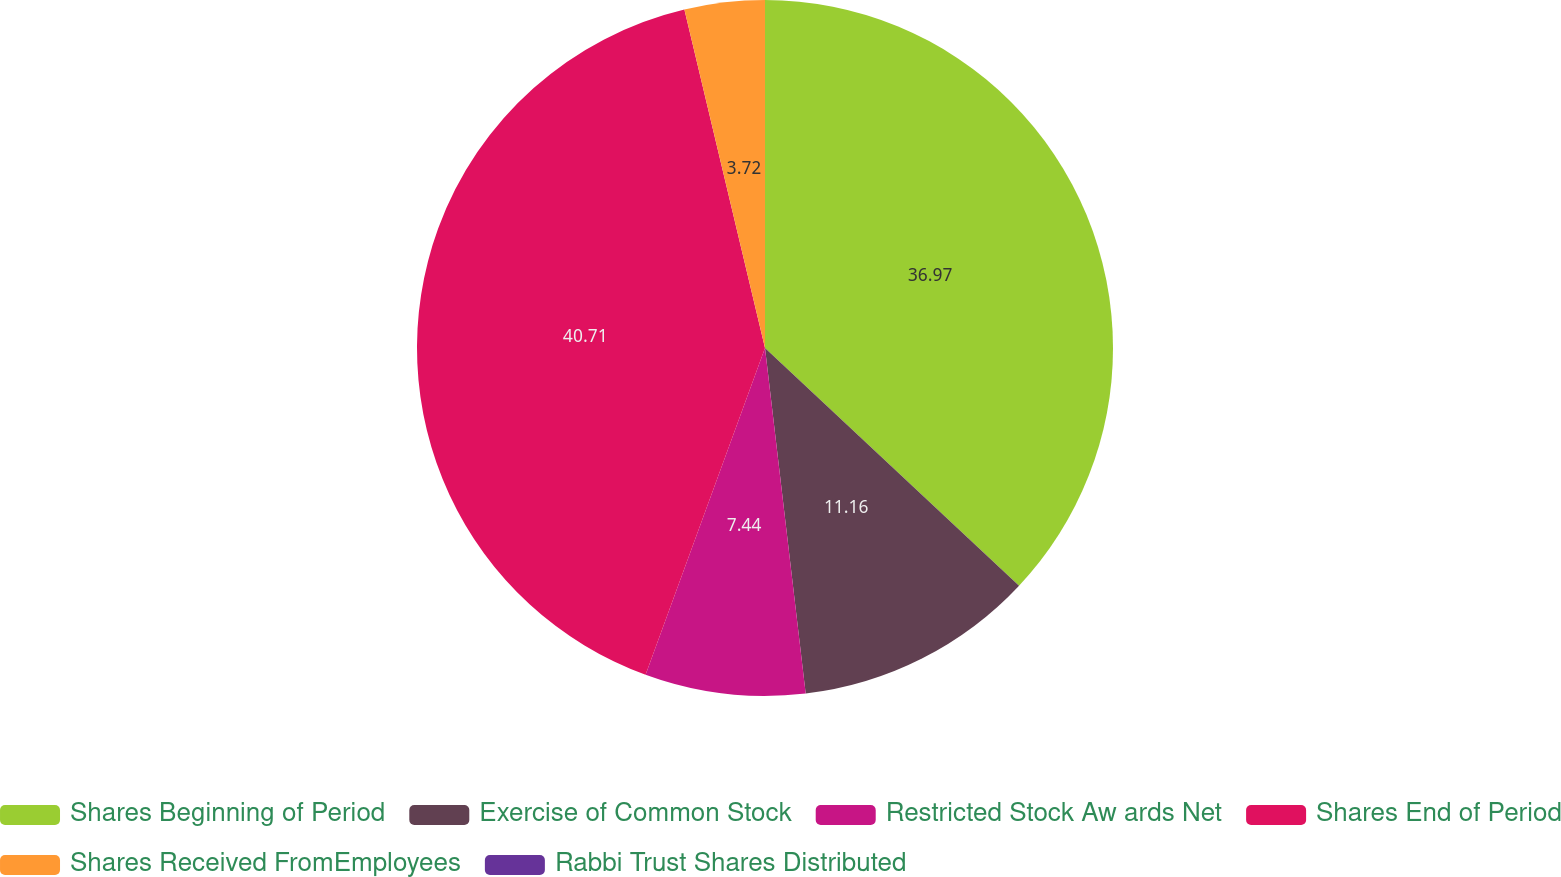Convert chart to OTSL. <chart><loc_0><loc_0><loc_500><loc_500><pie_chart><fcel>Shares Beginning of Period<fcel>Exercise of Common Stock<fcel>Restricted Stock Aw ards Net<fcel>Shares End of Period<fcel>Shares Received FromEmployees<fcel>Rabbi Trust Shares Distributed<nl><fcel>36.97%<fcel>11.16%<fcel>7.44%<fcel>40.7%<fcel>3.72%<fcel>0.0%<nl></chart> 